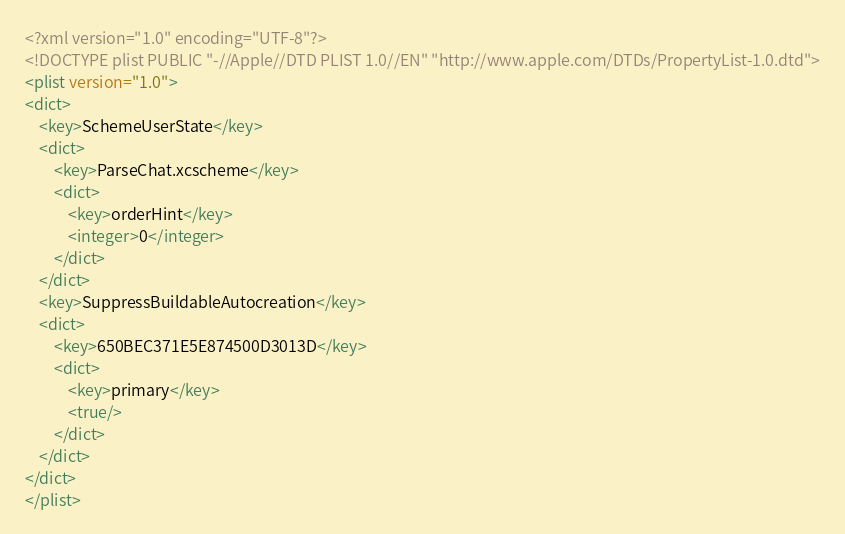Convert code to text. <code><loc_0><loc_0><loc_500><loc_500><_XML_><?xml version="1.0" encoding="UTF-8"?>
<!DOCTYPE plist PUBLIC "-//Apple//DTD PLIST 1.0//EN" "http://www.apple.com/DTDs/PropertyList-1.0.dtd">
<plist version="1.0">
<dict>
	<key>SchemeUserState</key>
	<dict>
		<key>ParseChat.xcscheme</key>
		<dict>
			<key>orderHint</key>
			<integer>0</integer>
		</dict>
	</dict>
	<key>SuppressBuildableAutocreation</key>
	<dict>
		<key>650BEC371E5E874500D3013D</key>
		<dict>
			<key>primary</key>
			<true/>
		</dict>
	</dict>
</dict>
</plist>
</code> 